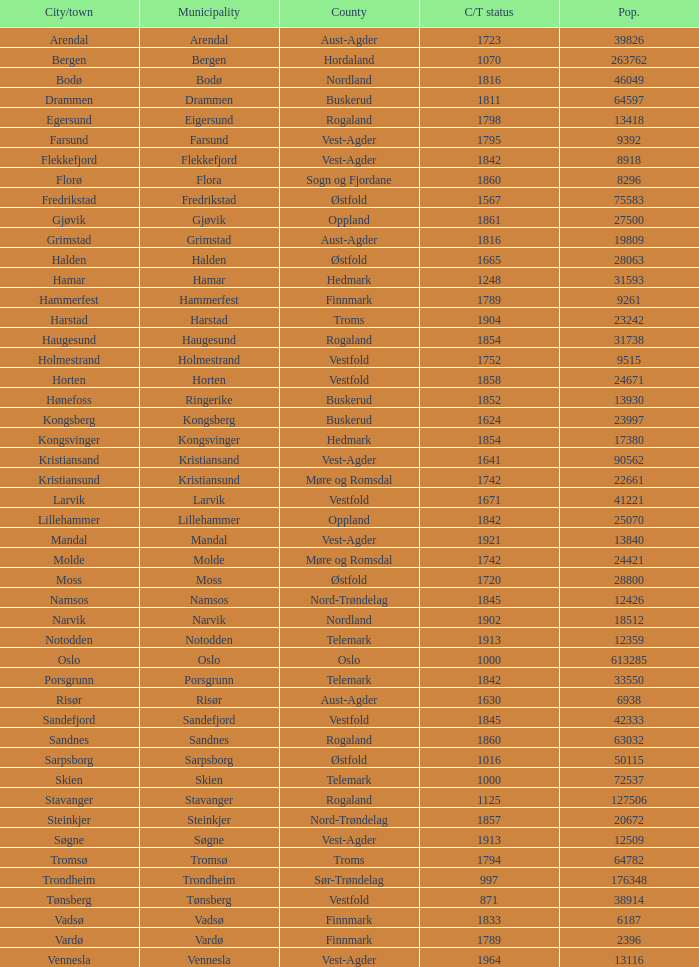Which municipality has a population of 24421? Molde. 